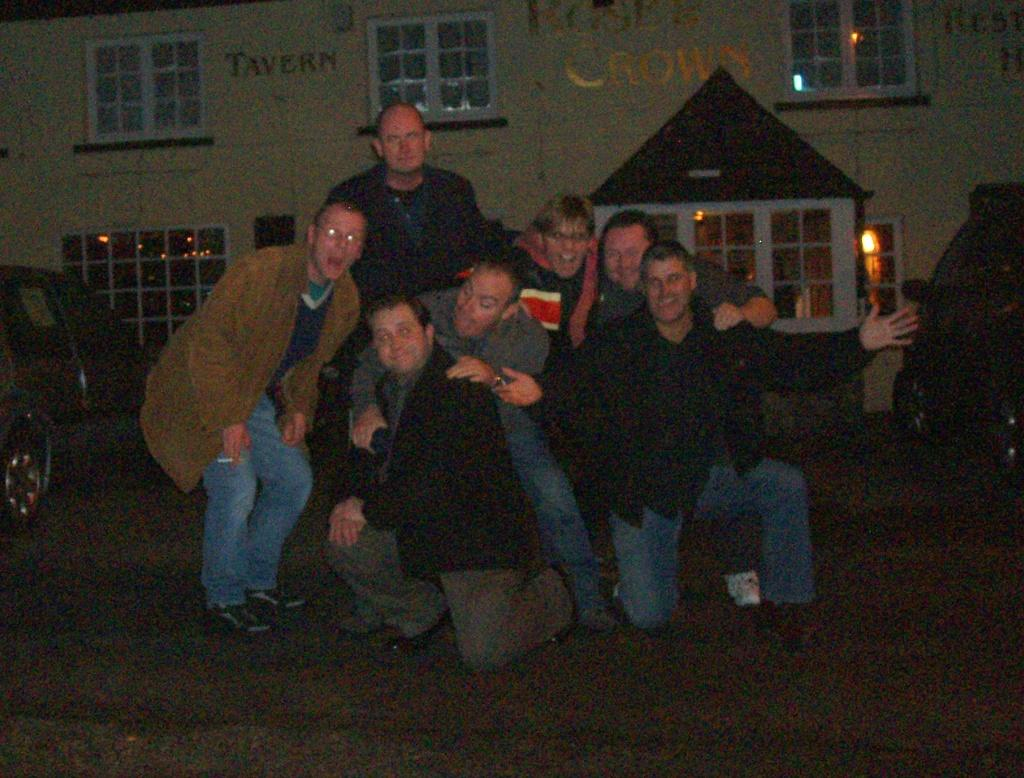What is happening in the foreground of the image? There are men in the foreground of the image, some of whom are kneeling downing down and some of whom are standing. What are the men doing in the image? They are posing for the camera. What can be seen in the background of the image? There are vehicles and at least one building in the background of the image. What type of holiday is being celebrated in the image? There is no indication of a holiday being celebrated in the image. On which side of the men are the vehicles located? The vehicles are located in the background of the image, and their specific position relative to the men cannot be determined from the provided facts. 